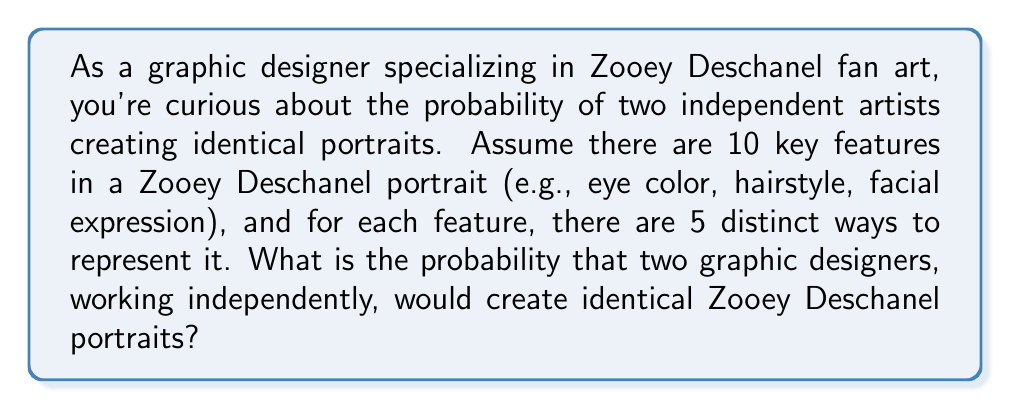Teach me how to tackle this problem. To solve this problem, we need to consider the following steps:

1. Calculate the total number of possible portrait combinations:
   Since there are 10 features, each with 5 options, the total number of possible portraits is:
   $$ 5^{10} $$

2. The probability of the two artists creating identical portraits is the same as the probability of the second artist creating the exact same portrait as the first artist.

3. For the second artist to create an identical portrait, they must choose the same option for each of the 10 features. The probability of this happening for each feature is $\frac{1}{5}$.

4. Since the features are independent, we multiply the probabilities:
   $$ P(\text{identical portraits}) = \left(\frac{1}{5}\right)^{10} $$

5. Simplify the expression:
   $$ P(\text{identical portraits}) = \frac{1}{5^{10}} = \frac{1}{9,765,625} $$

This extremely small probability demonstrates how unlikely it is for two independent artists to create identical Zooey Deschanel portraits, given the number of variables involved in the creative process.
Answer: The probability of two independent graphic designers creating identical Zooey Deschanel portraits is $\frac{1}{5^{10}} = \frac{1}{9,765,625}$, or approximately $1.024 \times 10^{-7}$. 